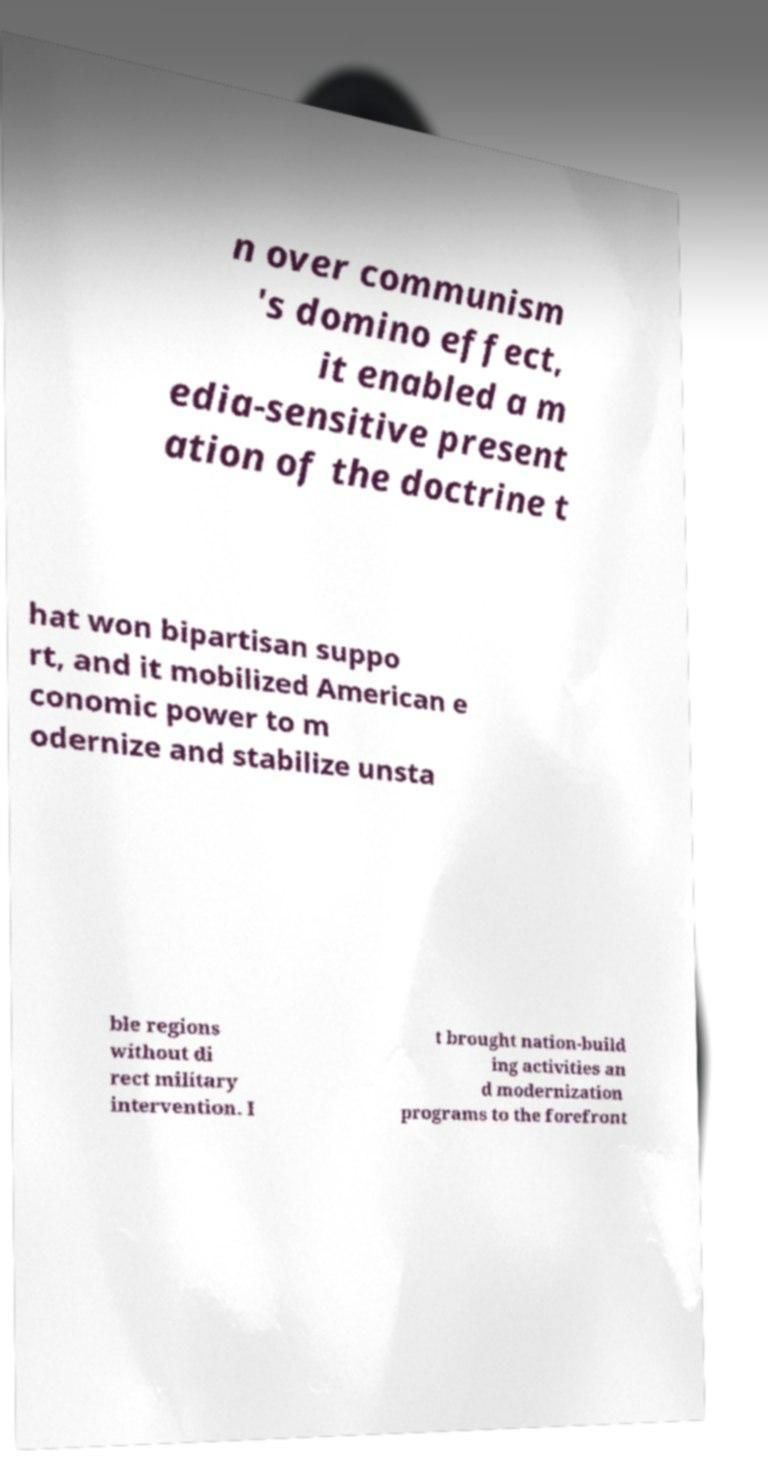Please read and relay the text visible in this image. What does it say? n over communism 's domino effect, it enabled a m edia-sensitive present ation of the doctrine t hat won bipartisan suppo rt, and it mobilized American e conomic power to m odernize and stabilize unsta ble regions without di rect military intervention. I t brought nation-build ing activities an d modernization programs to the forefront 